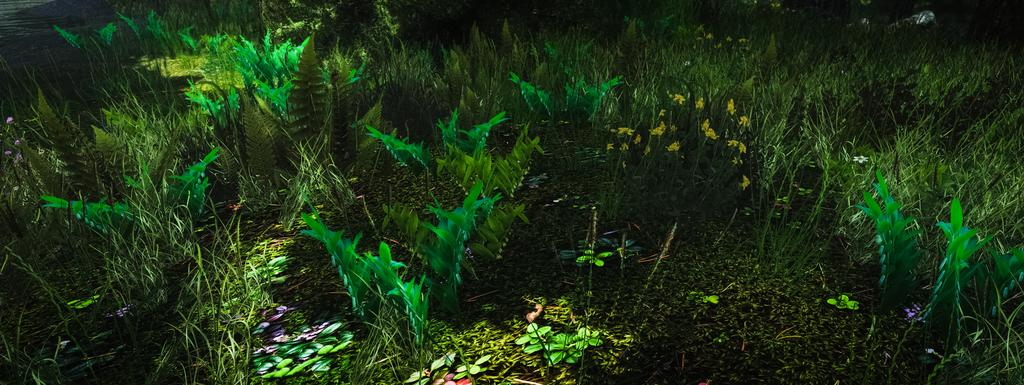What type of image is being described? The image is animated. What type of vegetation can be seen in the image? There is grass and small plants in the image. Where are the grass and small plants located in the image? The grass and small plants are on the ground. How much credit is given to the rock in the image? There is no rock present in the image, so credit cannot be given to a rock. 